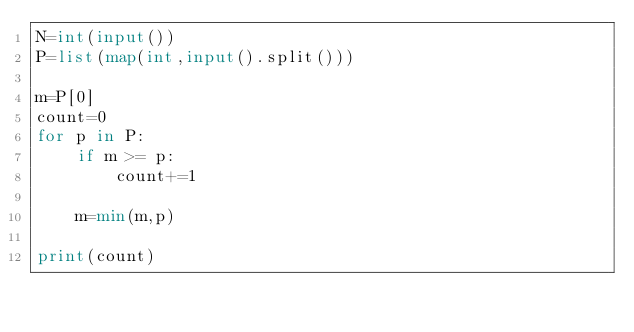Convert code to text. <code><loc_0><loc_0><loc_500><loc_500><_Python_>N=int(input())
P=list(map(int,input().split()))

m=P[0]
count=0
for p in P:
    if m >= p:
        count+=1

    m=min(m,p)

print(count)
</code> 